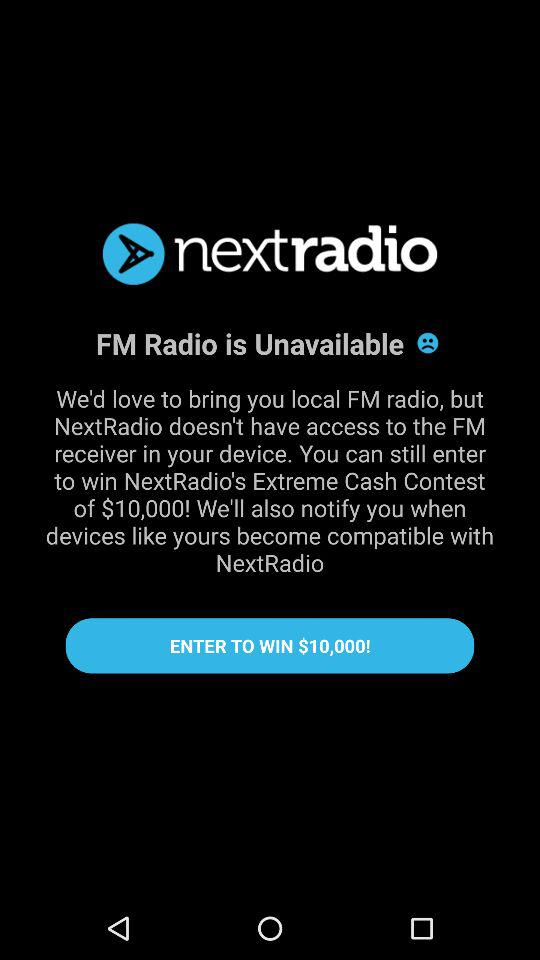What is the application name? The application name is "nextradio". 